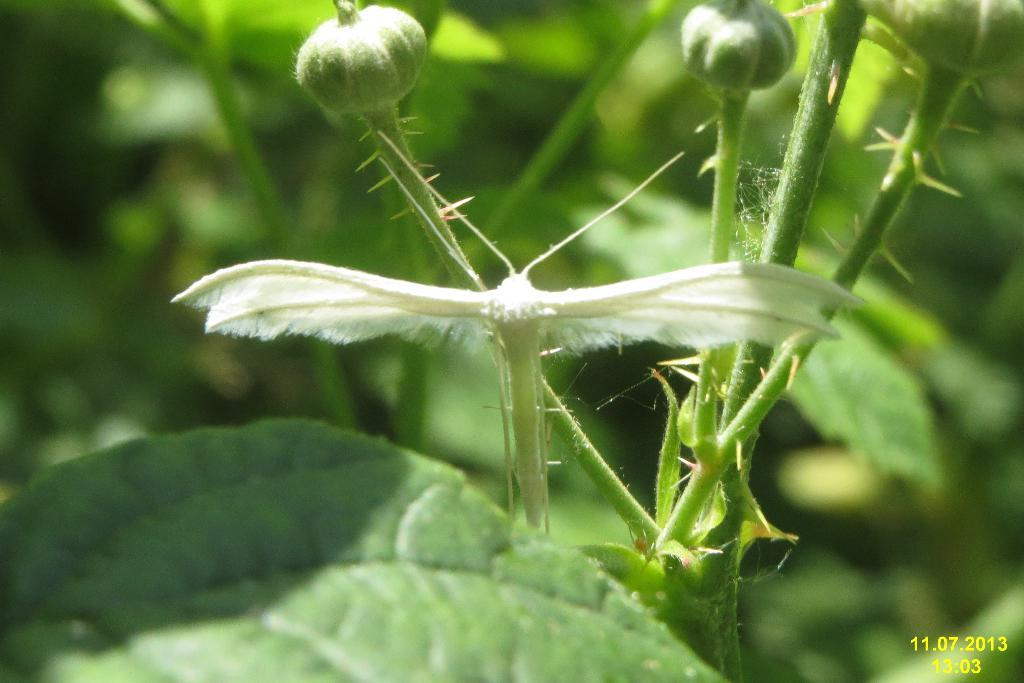What type of creature is in the image? There is a white insect in the image. Where is the insect located? The insect is on a stem. What other elements can be seen in the image? There are green leaves in the image. What type of corn is being harvested in the image? There is no corn present in the image; it features a white insect on a stem surrounded by green leaves. 